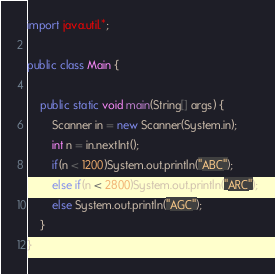Convert code to text. <code><loc_0><loc_0><loc_500><loc_500><_Java_>import java.util.*;

public class Main {
	
	public static void main(String[] args) {
		Scanner in = new Scanner(System.in);
		int n = in.nextInt();
		if(n < 1200)System.out.println("ABC");
		else if(n < 2800)System.out.println("ARC");
		else System.out.println("AGC");
	}
}
</code> 